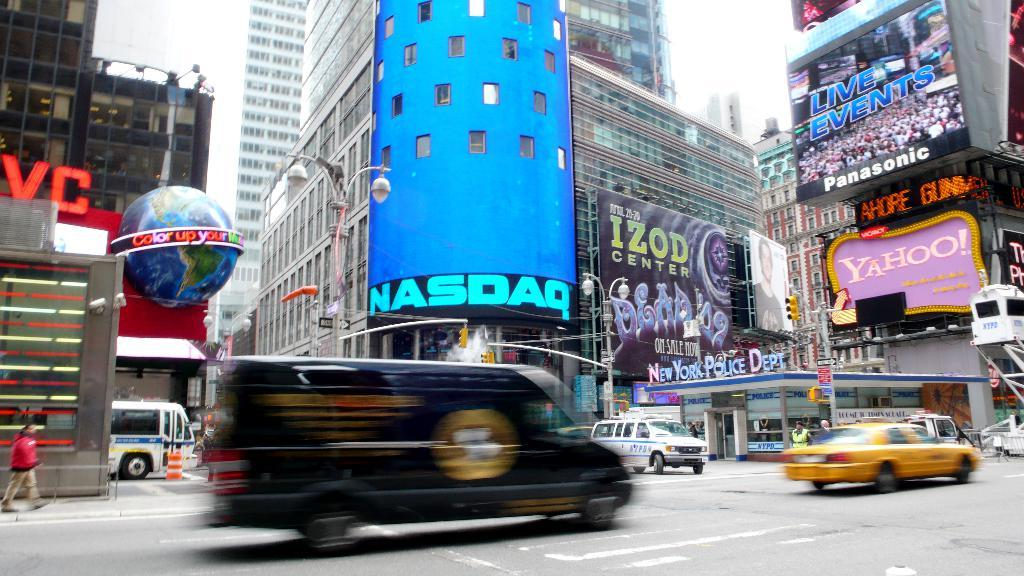<image>
Provide a brief description of the given image. A black van is driving through an intersection where a large sign says NASDAQ. 